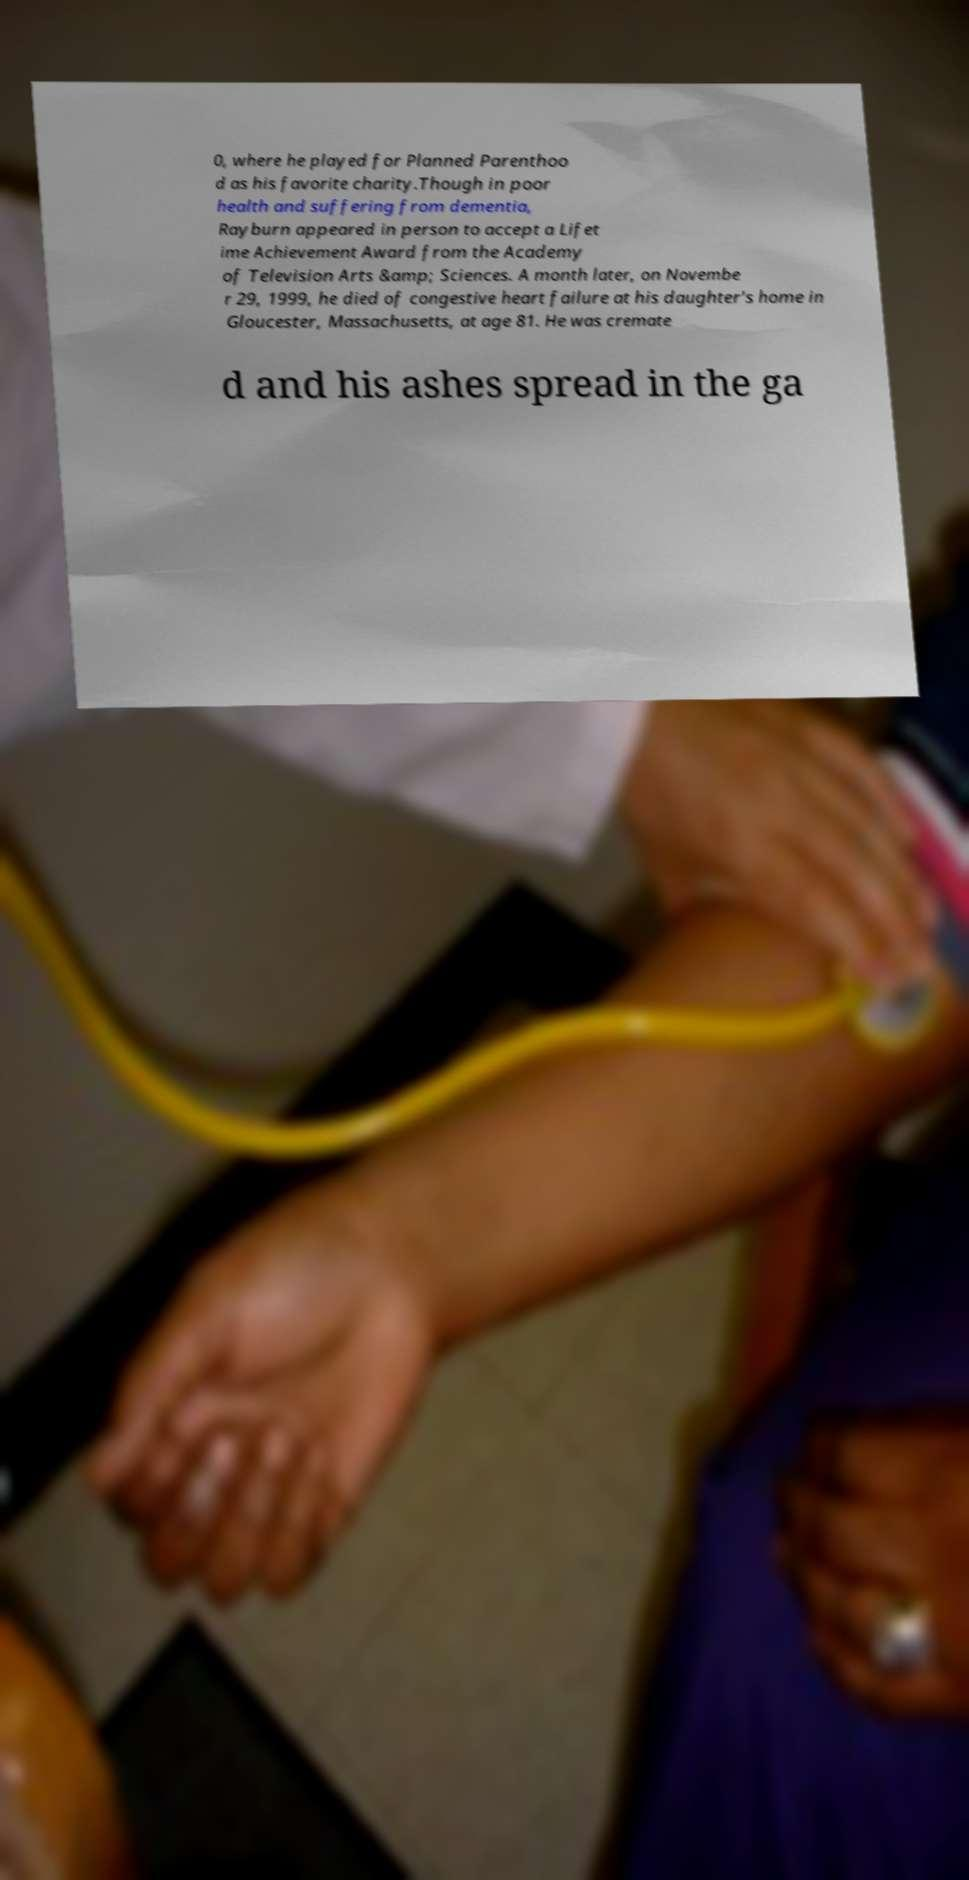What messages or text are displayed in this image? I need them in a readable, typed format. 0, where he played for Planned Parenthoo d as his favorite charity.Though in poor health and suffering from dementia, Rayburn appeared in person to accept a Lifet ime Achievement Award from the Academy of Television Arts &amp; Sciences. A month later, on Novembe r 29, 1999, he died of congestive heart failure at his daughter's home in Gloucester, Massachusetts, at age 81. He was cremate d and his ashes spread in the ga 